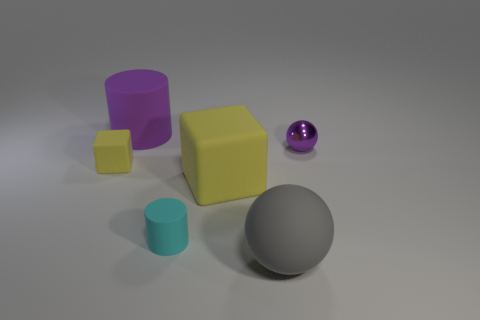Add 3 tiny metallic objects. How many tiny metallic objects exist? 4 Add 4 brown cubes. How many objects exist? 10 Subtract all cyan cylinders. How many cylinders are left? 1 Subtract 1 gray spheres. How many objects are left? 5 Subtract all cylinders. How many objects are left? 4 Subtract 1 blocks. How many blocks are left? 1 Subtract all cyan spheres. Subtract all brown cylinders. How many spheres are left? 2 Subtract all blue cylinders. How many yellow balls are left? 0 Subtract all blue rubber spheres. Subtract all purple spheres. How many objects are left? 5 Add 1 large yellow blocks. How many large yellow blocks are left? 2 